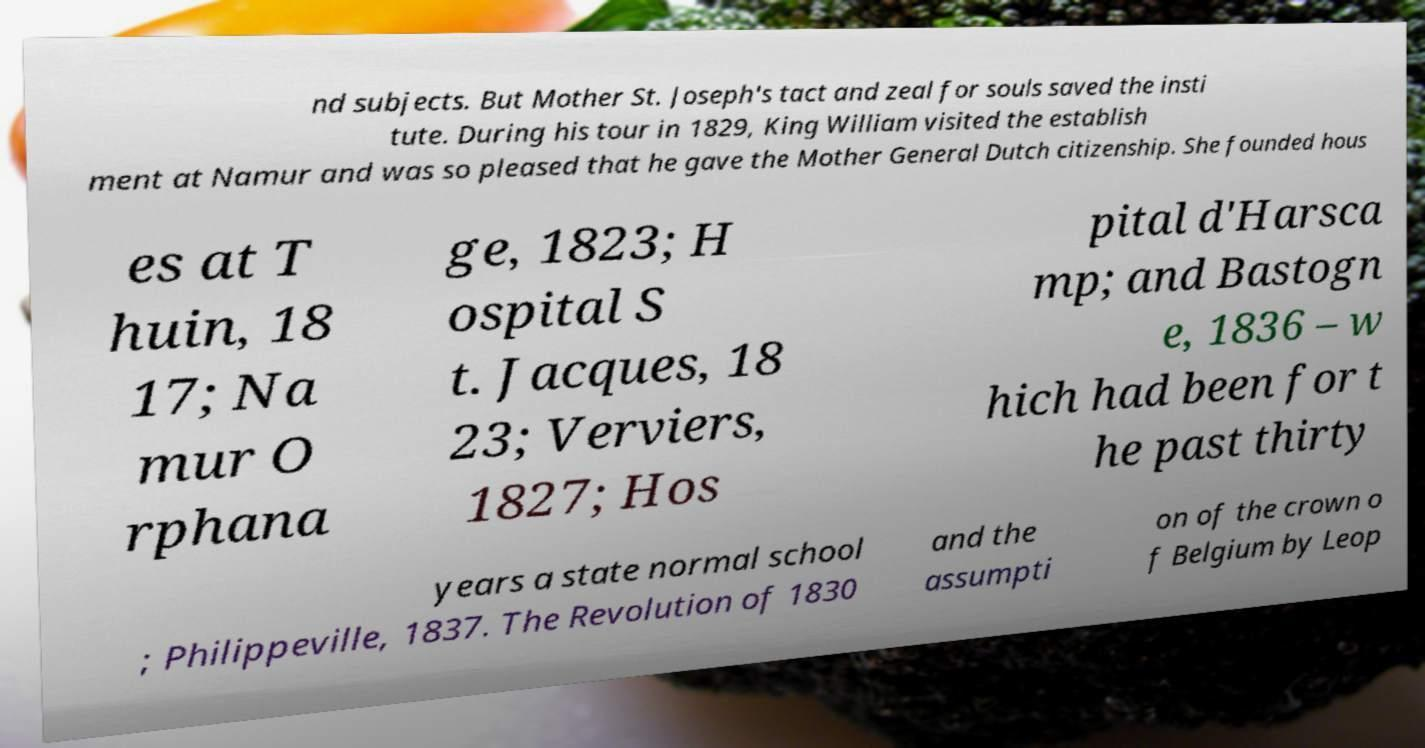Please identify and transcribe the text found in this image. nd subjects. But Mother St. Joseph's tact and zeal for souls saved the insti tute. During his tour in 1829, King William visited the establish ment at Namur and was so pleased that he gave the Mother General Dutch citizenship. She founded hous es at T huin, 18 17; Na mur O rphana ge, 1823; H ospital S t. Jacques, 18 23; Verviers, 1827; Hos pital d'Harsca mp; and Bastogn e, 1836 – w hich had been for t he past thirty years a state normal school ; Philippeville, 1837. The Revolution of 1830 and the assumpti on of the crown o f Belgium by Leop 